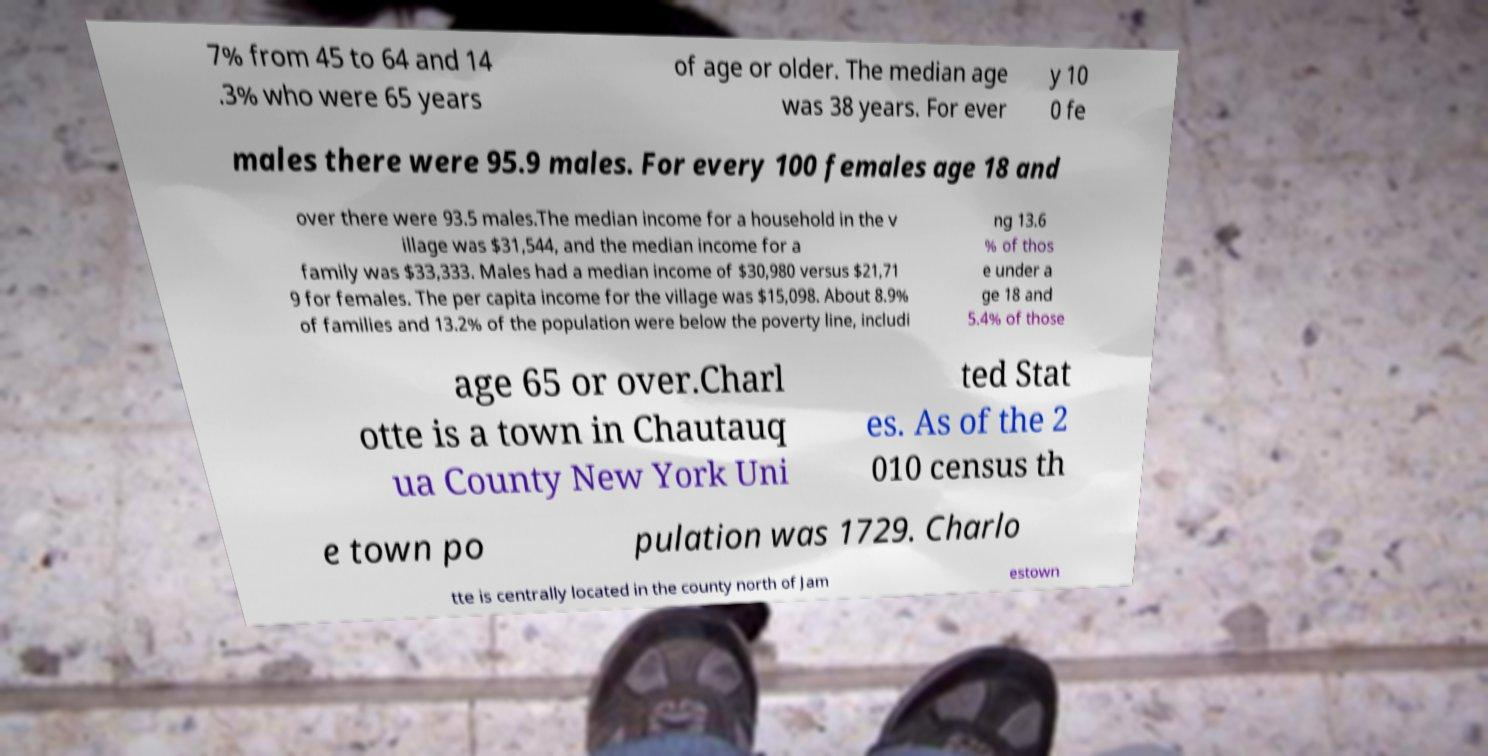Can you read and provide the text displayed in the image?This photo seems to have some interesting text. Can you extract and type it out for me? 7% from 45 to 64 and 14 .3% who were 65 years of age or older. The median age was 38 years. For ever y 10 0 fe males there were 95.9 males. For every 100 females age 18 and over there were 93.5 males.The median income for a household in the v illage was $31,544, and the median income for a family was $33,333. Males had a median income of $30,980 versus $21,71 9 for females. The per capita income for the village was $15,098. About 8.9% of families and 13.2% of the population were below the poverty line, includi ng 13.6 % of thos e under a ge 18 and 5.4% of those age 65 or over.Charl otte is a town in Chautauq ua County New York Uni ted Stat es. As of the 2 010 census th e town po pulation was 1729. Charlo tte is centrally located in the county north of Jam estown 